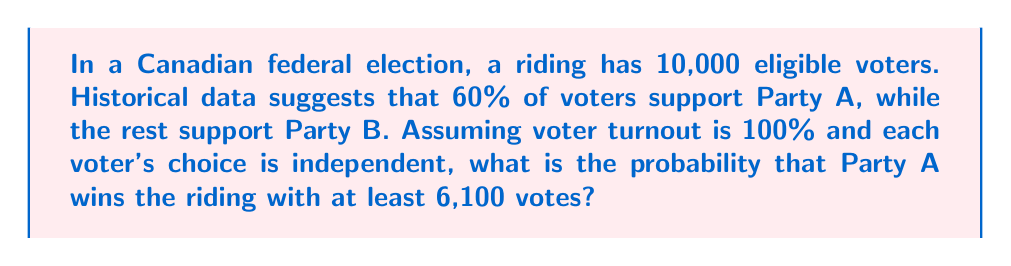Show me your answer to this math problem. To solve this problem, we'll use the binomial distribution and follow these steps:

1) First, we identify the parameters of our binomial distribution:
   $n = 10,000$ (number of trials)
   $p = 0.60$ (probability of success, i.e., voting for Party A)

2) We want to find the probability of Party A getting at least 6,100 votes. This can be expressed as:

   $P(X \geq 6100)$ where $X$ follows $B(10000, 0.60)$

3) Using the properties of probability, we can rewrite this as:

   $P(X \geq 6100) = 1 - P(X < 6100) = 1 - P(X \leq 6099)$

4) The probability $P(X \leq 6099)$ can be calculated using the cumulative binomial distribution function:

   $$P(X \leq 6099) = \sum_{k=0}^{6099} \binom{10000}{k} (0.60)^k (0.40)^{10000-k}$$

5) This sum is computationally intensive, so we'll use the normal approximation to the binomial distribution. This is valid because $n$ is large and $np(1-p) > 5$.

6) For a normal approximation, we need the mean and standard deviation:
   $\mu = np = 10000 \cdot 0.60 = 6000$
   $\sigma = \sqrt{np(1-p)} = \sqrt{10000 \cdot 0.60 \cdot 0.40} = \sqrt{2400} \approx 48.99$

7) We then calculate the z-score:
   $z = \frac{6099.5 - 6000}{48.99} \approx 2.03$
   (We use 6099.5 for continuity correction)

8) Using a standard normal distribution table or calculator, we find:
   $P(Z \leq 2.03) \approx 0.9788$

9) Therefore, $P(X \geq 6100) = 1 - 0.9788 = 0.0212$
Answer: $0.0212$ or $2.12\%$ 